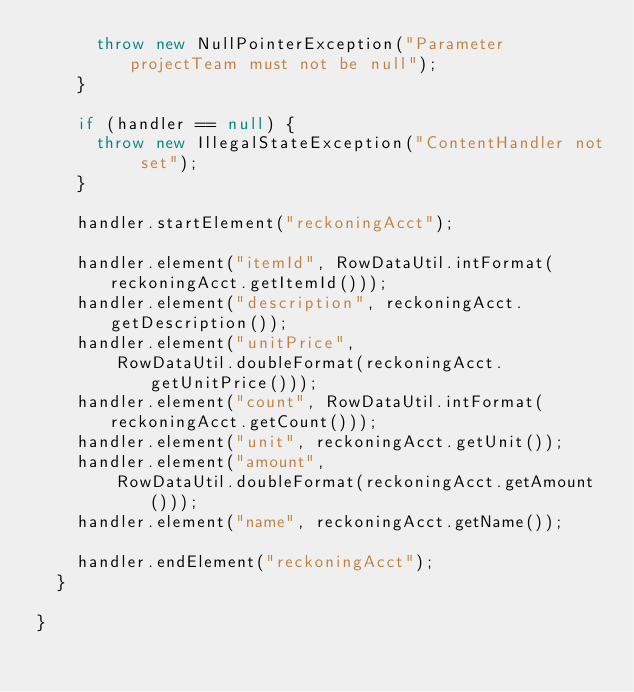Convert code to text. <code><loc_0><loc_0><loc_500><loc_500><_Java_>      throw new NullPointerException("Parameter projectTeam must not be null");
    }

    if (handler == null) {
      throw new IllegalStateException("ContentHandler not set");
    }

    handler.startElement("reckoningAcct");

    handler.element("itemId", RowDataUtil.intFormat(reckoningAcct.getItemId()));
    handler.element("description", reckoningAcct.getDescription());
    handler.element("unitPrice",
        RowDataUtil.doubleFormat(reckoningAcct.getUnitPrice()));
    handler.element("count", RowDataUtil.intFormat(reckoningAcct.getCount()));
    handler.element("unit", reckoningAcct.getUnit());
    handler.element("amount",
        RowDataUtil.doubleFormat(reckoningAcct.getAmount()));
    handler.element("name", reckoningAcct.getName());

    handler.endElement("reckoningAcct");
  }

}
</code> 